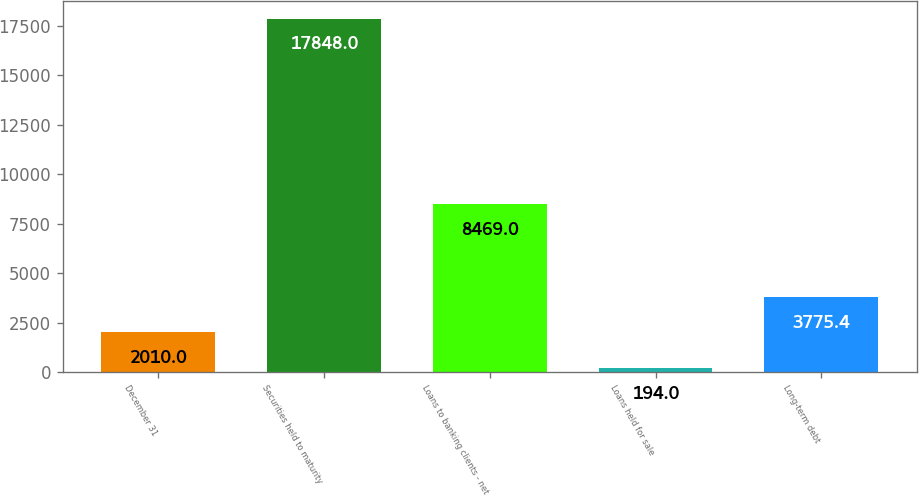Convert chart to OTSL. <chart><loc_0><loc_0><loc_500><loc_500><bar_chart><fcel>December 31<fcel>Securities held to maturity<fcel>Loans to banking clients - net<fcel>Loans held for sale<fcel>Long-term debt<nl><fcel>2010<fcel>17848<fcel>8469<fcel>194<fcel>3775.4<nl></chart> 